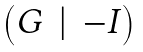Convert formula to latex. <formula><loc_0><loc_0><loc_500><loc_500>\begin{pmatrix} G & | & - I \end{pmatrix}</formula> 